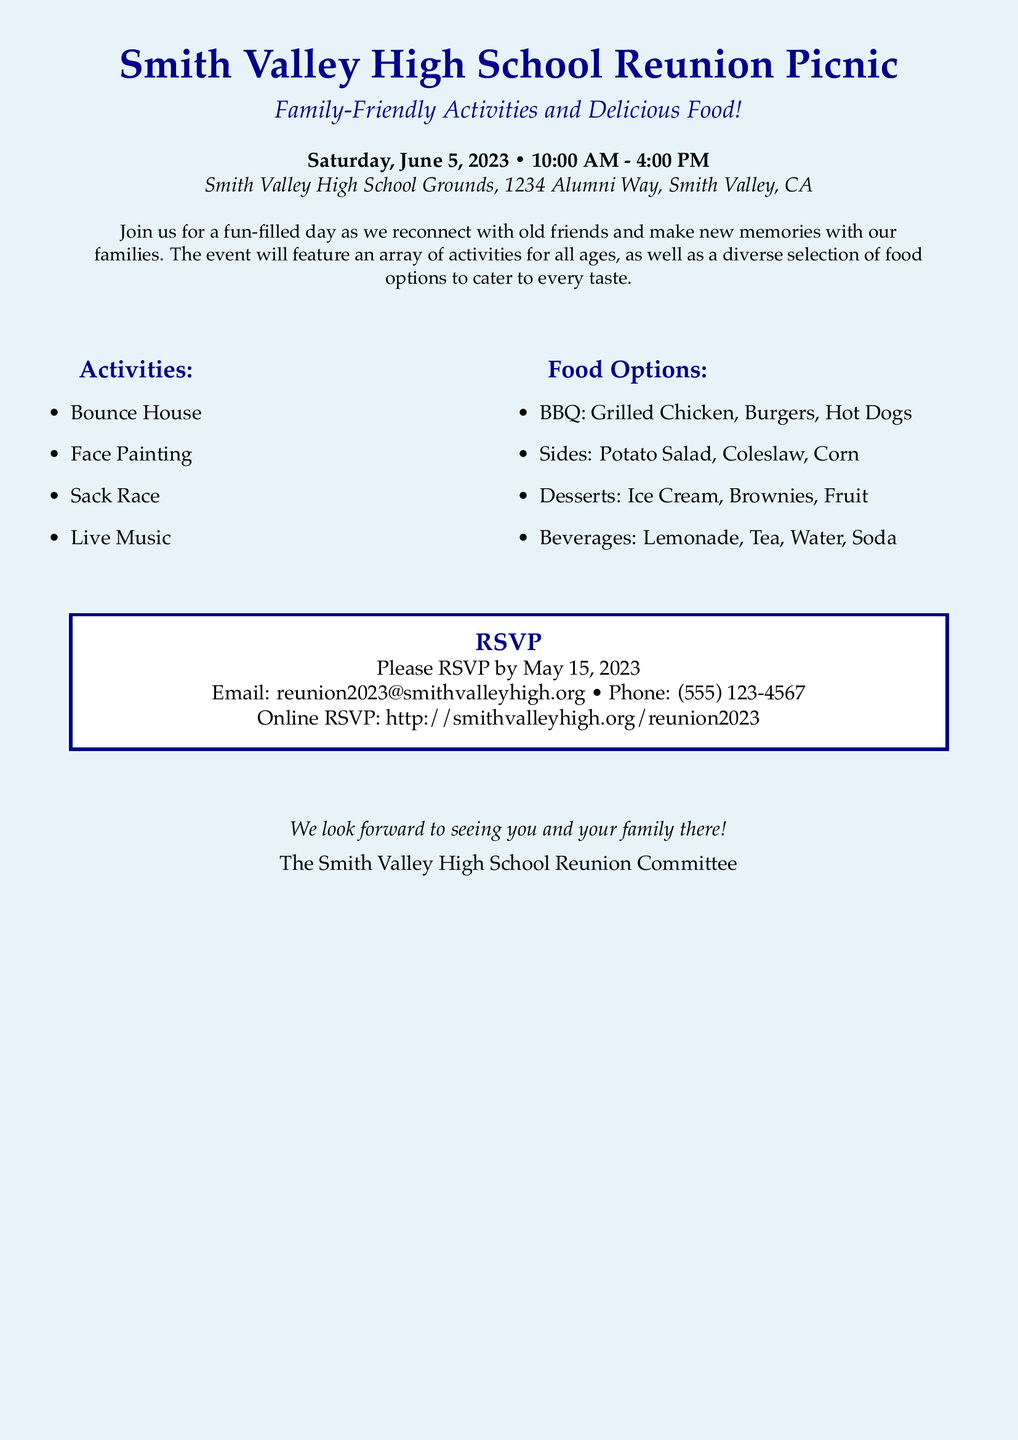What date is the reunion picnic? The document clearly states the date of the picnic, which is Saturday, June 5, 2023.
Answer: June 5, 2023 What activities are available at the picnic? The document lists the activities, including Bounce House, Face Painting, Sack Race, and Live Music.
Answer: Bounce House, Face Painting, Sack Race, Live Music What is the RSVP deadline? The RSVP deadline is mentioned directly in the document as May 15, 2023.
Answer: May 15, 2023 What food options are offered at the reunion? The document lists several food options such as BBQ, Sides, Desserts, and Beverages.
Answer: BBQ, Sides, Desserts, Beverages Where is the picnic being held? The location is specified in the document as Smith Valley High School Grounds, 1234 Alumni Way, Smith Valley, CA.
Answer: Smith Valley High School Grounds, 1234 Alumni Way, Smith Valley, CA How can guests RSVP? The document provides multiple ways to RSVP, including email, phone, and online link.
Answer: Email, phone, online link What time does the picnic start? The starting time for the picnic is clearly stated in the document.
Answer: 10:00 AM What is a dessert option available at the picnic? The document lists Ice Cream, Brownies, and Fruit as dessert options.
Answer: Ice Cream, Brownies, Fruit Who is looking forward to seeing the attendees? The document specifies that the Smith Valley High School Reunion Committee looks forward to seeing attendees.
Answer: The Smith Valley High School Reunion Committee 